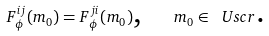Convert formula to latex. <formula><loc_0><loc_0><loc_500><loc_500>F _ { \phi } ^ { i j } ( m _ { 0 } ) = F _ { \phi } ^ { j i } ( m _ { 0 } ) \text {,} \quad m _ { 0 } \in \ U s c r \text {.}</formula> 